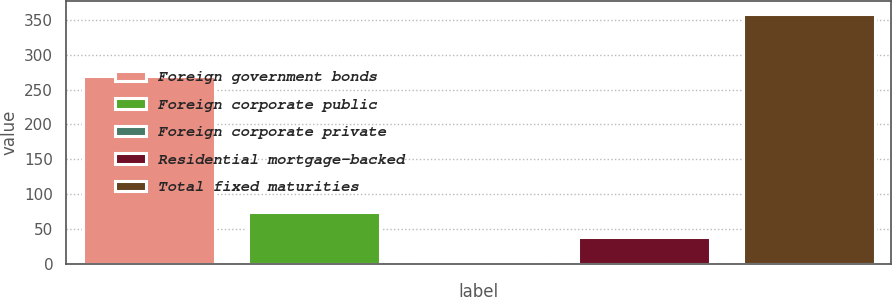Convert chart. <chart><loc_0><loc_0><loc_500><loc_500><bar_chart><fcel>Foreign government bonds<fcel>Foreign corporate public<fcel>Foreign corporate private<fcel>Residential mortgage-backed<fcel>Total fixed maturities<nl><fcel>269<fcel>74.2<fcel>3<fcel>38.6<fcel>359<nl></chart> 